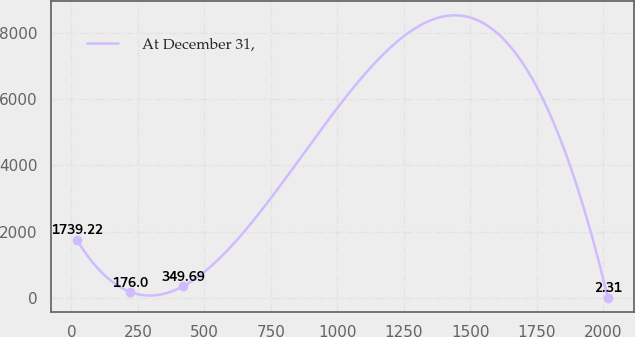Convert chart to OTSL. <chart><loc_0><loc_0><loc_500><loc_500><line_chart><ecel><fcel>At December 31,<nl><fcel>21.35<fcel>1739.22<nl><fcel>220.99<fcel>176<nl><fcel>420.62<fcel>349.69<nl><fcel>2017.7<fcel>2.31<nl></chart> 